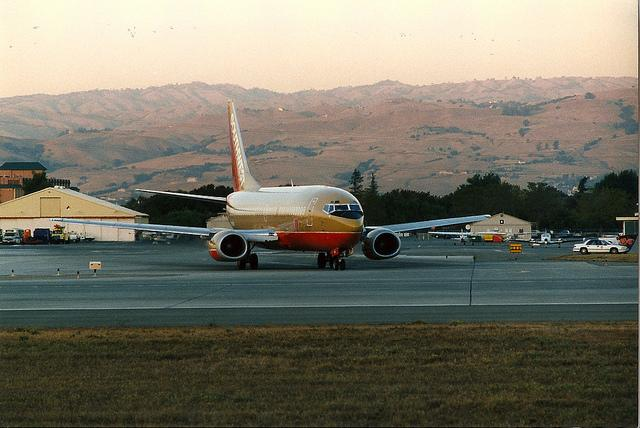What is the plane doing that requires it to be perpendicular to the runway?

Choices:
A) taking off
B) boarding
C) taxiing
D) landing taxiing 